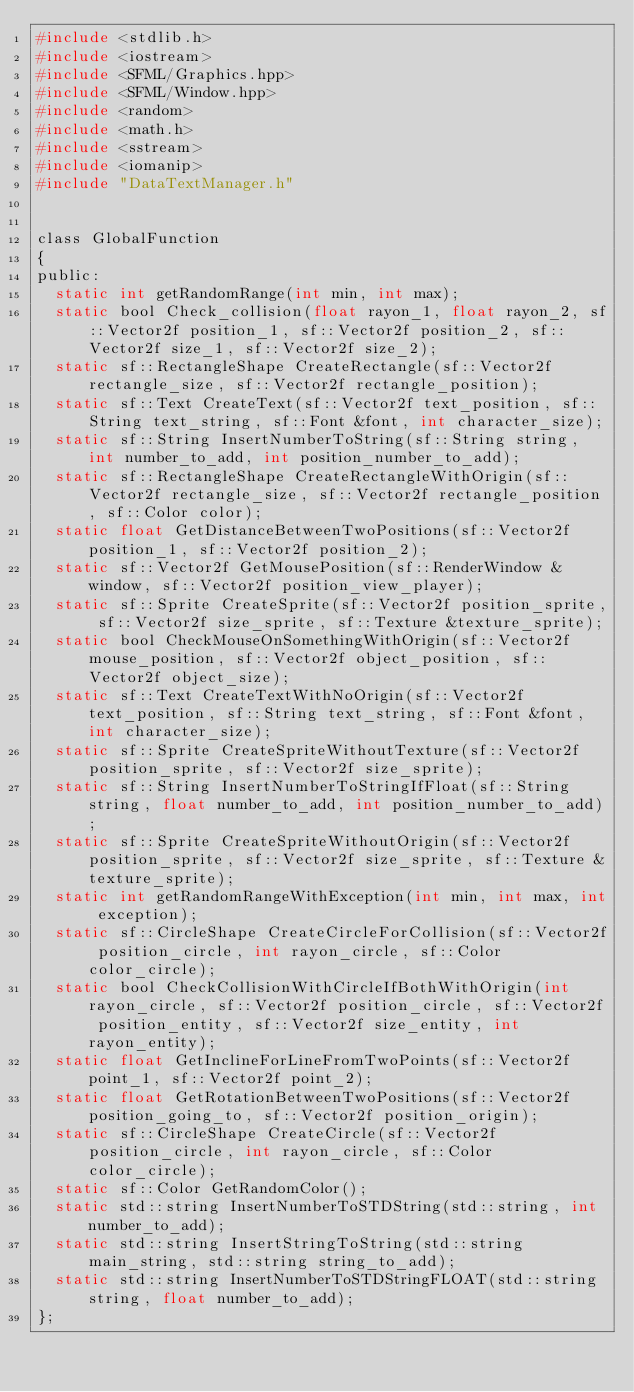Convert code to text. <code><loc_0><loc_0><loc_500><loc_500><_C_>#include <stdlib.h>
#include <iostream>
#include <SFML/Graphics.hpp>
#include <SFML/Window.hpp>
#include <random>
#include <math.h>
#include <sstream>
#include <iomanip>
#include "DataTextManager.h"


class GlobalFunction
{
public:
	static int getRandomRange(int min, int max);
	static bool Check_collision(float rayon_1, float rayon_2, sf::Vector2f position_1, sf::Vector2f position_2, sf::Vector2f size_1, sf::Vector2f size_2);
	static sf::RectangleShape CreateRectangle(sf::Vector2f rectangle_size, sf::Vector2f rectangle_position);
	static sf::Text CreateText(sf::Vector2f text_position, sf::String text_string, sf::Font &font, int character_size);
	static sf::String InsertNumberToString(sf::String string, int number_to_add, int position_number_to_add);
	static sf::RectangleShape CreateRectangleWithOrigin(sf::Vector2f rectangle_size, sf::Vector2f rectangle_position, sf::Color color);
	static float GetDistanceBetweenTwoPositions(sf::Vector2f position_1, sf::Vector2f position_2);
	static sf::Vector2f GetMousePosition(sf::RenderWindow &window, sf::Vector2f position_view_player);
	static sf::Sprite CreateSprite(sf::Vector2f position_sprite, sf::Vector2f size_sprite, sf::Texture &texture_sprite);
	static bool CheckMouseOnSomethingWithOrigin(sf::Vector2f mouse_position, sf::Vector2f object_position, sf::Vector2f object_size);
	static sf::Text CreateTextWithNoOrigin(sf::Vector2f text_position, sf::String text_string, sf::Font &font, int character_size);
	static sf::Sprite CreateSpriteWithoutTexture(sf::Vector2f position_sprite, sf::Vector2f size_sprite);
	static sf::String InsertNumberToStringIfFloat(sf::String string, float number_to_add, int position_number_to_add);
	static sf::Sprite CreateSpriteWithoutOrigin(sf::Vector2f position_sprite, sf::Vector2f size_sprite, sf::Texture &texture_sprite);
	static int getRandomRangeWithException(int min, int max, int exception);
	static sf::CircleShape CreateCircleForCollision(sf::Vector2f position_circle, int rayon_circle, sf::Color color_circle);
	static bool CheckCollisionWithCircleIfBothWithOrigin(int rayon_circle, sf::Vector2f position_circle, sf::Vector2f position_entity, sf::Vector2f size_entity, int rayon_entity);
	static float GetInclineForLineFromTwoPoints(sf::Vector2f point_1, sf::Vector2f point_2);
	static float GetRotationBetweenTwoPositions(sf::Vector2f position_going_to, sf::Vector2f position_origin);
	static sf::CircleShape CreateCircle(sf::Vector2f position_circle, int rayon_circle, sf::Color color_circle);
	static sf::Color GetRandomColor();
	static std::string InsertNumberToSTDString(std::string, int number_to_add);
	static std::string InsertStringToString(std::string main_string, std::string string_to_add);
	static std::string InsertNumberToSTDStringFLOAT(std::string string, float number_to_add);
};

</code> 